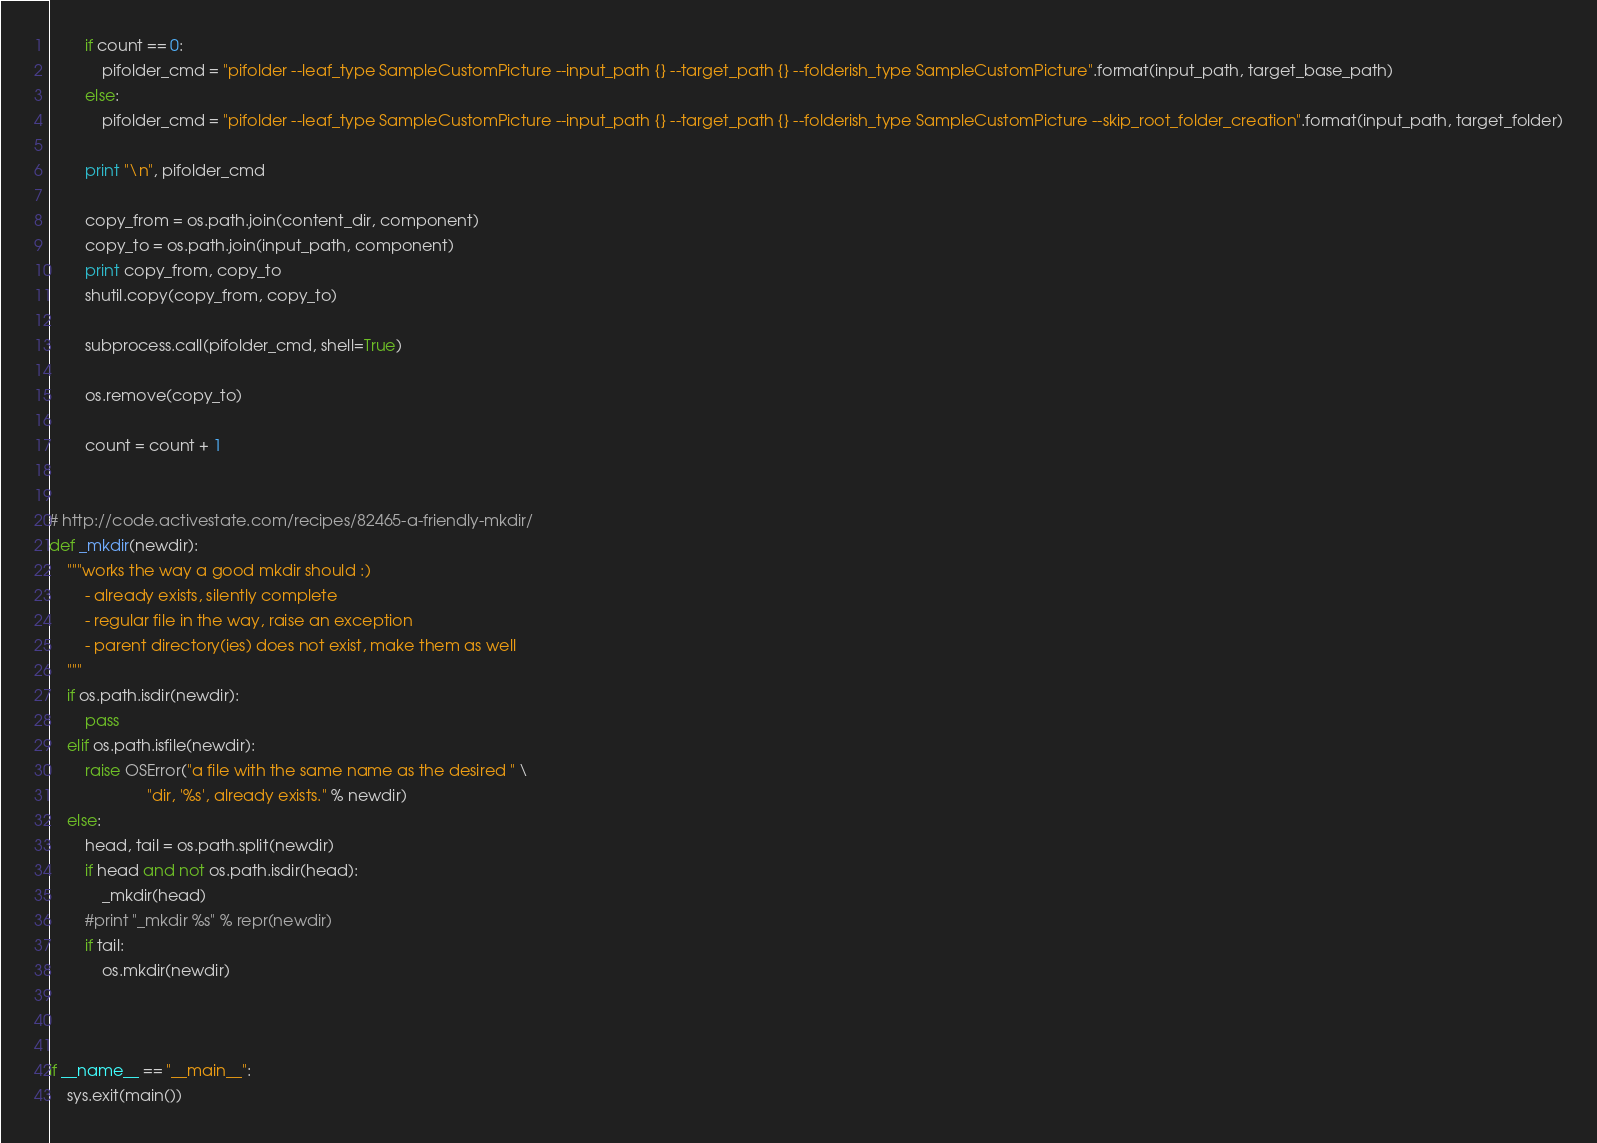Convert code to text. <code><loc_0><loc_0><loc_500><loc_500><_Python_>        if count == 0:
            pifolder_cmd = "pifolder --leaf_type SampleCustomPicture --input_path {} --target_path {} --folderish_type SampleCustomPicture".format(input_path, target_base_path)
        else:
            pifolder_cmd = "pifolder --leaf_type SampleCustomPicture --input_path {} --target_path {} --folderish_type SampleCustomPicture --skip_root_folder_creation".format(input_path, target_folder)

        print "\n", pifolder_cmd

        copy_from = os.path.join(content_dir, component)
        copy_to = os.path.join(input_path, component)
        print copy_from, copy_to
        shutil.copy(copy_from, copy_to)

        subprocess.call(pifolder_cmd, shell=True)

        os.remove(copy_to)

        count = count + 1


# http://code.activestate.com/recipes/82465-a-friendly-mkdir/
def _mkdir(newdir):
    """works the way a good mkdir should :)
        - already exists, silently complete
        - regular file in the way, raise an exception
        - parent directory(ies) does not exist, make them as well
    """
    if os.path.isdir(newdir):
        pass
    elif os.path.isfile(newdir):
        raise OSError("a file with the same name as the desired " \
                      "dir, '%s', already exists." % newdir)
    else:
        head, tail = os.path.split(newdir)
        if head and not os.path.isdir(head):
            _mkdir(head)
        #print "_mkdir %s" % repr(newdir)
        if tail:
            os.mkdir(newdir)



if __name__ == "__main__":
    sys.exit(main())
</code> 